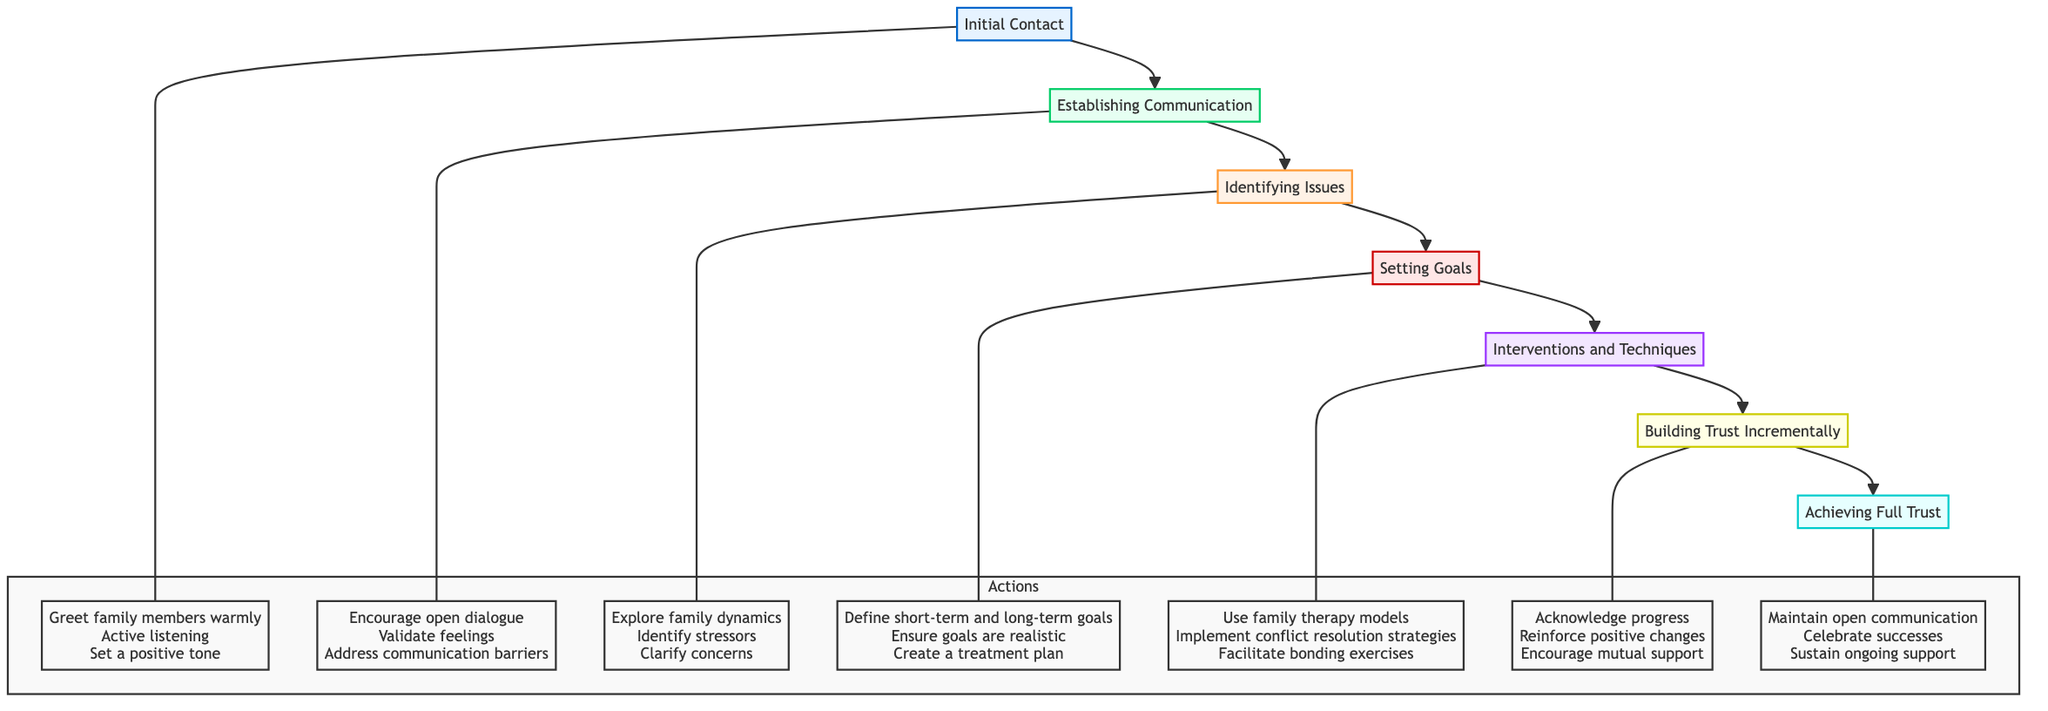What is the first step in the development of trust? The diagram indicates that the first step is "Initial Contact," which sets the stage for subsequent interactions.
Answer: Initial Contact How many levels are in the diagram? Counting the distinct nodes, there are seven levels in total, starting from Initial Contact and leading up to Achieving Full Trust.
Answer: 7 What is the primary action associated with "Building Trust Incrementally"? The primary actions connected to this node are "Acknowledge progress," "Reinforce positive changes," and "Encourage mutual support."
Answer: Acknowledge progress Which node directly follows "Setting Goals"? According to the flow of the diagram, "Interventions and Techniques" directly follows "Setting Goals," indicating a progression from goal-setting to implementing strategies.
Answer: Interventions and Techniques What type of goals are set during the "Setting Goals" phase? The goals set during this phase are described as "short-term and long-term," emphasizing that both immediate and future objectives are addressed.
Answer: short-term and long-term What are the three major actions in the "Identifying Issues" phase? The actions outlined in this phase consist of "Explore family dynamics," "Identify stressors," and "Clarify concerns," which together help in recognizing the core issues.
Answer: Explore family dynamics, Identify stressors, Clarify concerns What is the ultimate step in the development of trust? The final step indicated in the flow chart is "Achieving Full Trust," which suggests the culmination of all prior efforts in the therapeutic process.
Answer: Achieving Full Trust How do you know trust is being built in the "Building Trust Incrementally" phase? Trust is built through "repeated positive interactions and successful interventions," which signifies that ongoing experiences contribute to developing trust.
Answer: repeated positive interactions and successful interventions What is required for "Achieving Full Trust" to be maintained? Maintaining "open communication," "celebrating successes," and "sustaining ongoing support" are essential elements for achieving and retaining trust at this level.
Answer: open communication, celebrating successes, sustaining ongoing support 